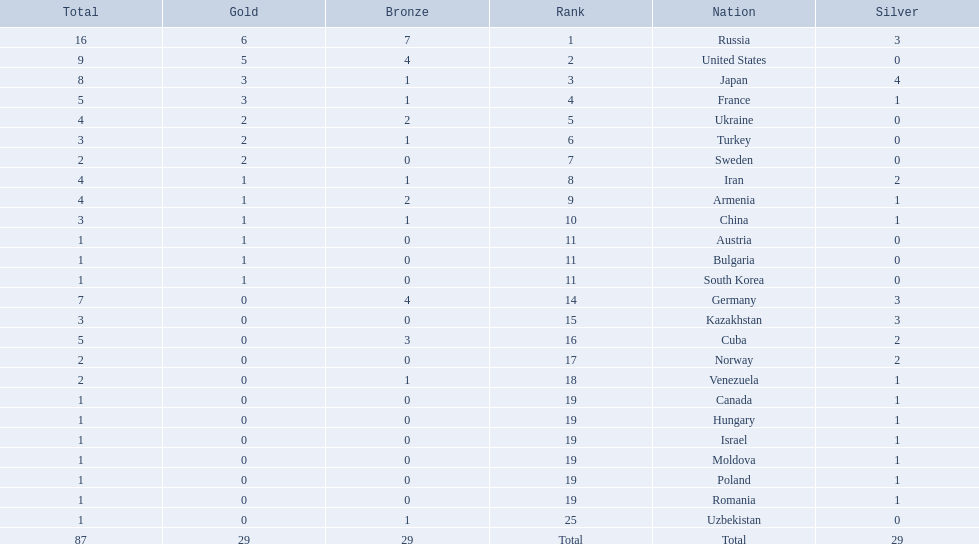Which nations only won less then 5 medals? Ukraine, Turkey, Sweden, Iran, Armenia, China, Austria, Bulgaria, South Korea, Germany, Kazakhstan, Norway, Venezuela, Canada, Hungary, Israel, Moldova, Poland, Romania, Uzbekistan. Which of these were not asian nations? Ukraine, Turkey, Sweden, Iran, Armenia, Austria, Bulgaria, Germany, Kazakhstan, Norway, Venezuela, Canada, Hungary, Israel, Moldova, Poland, Romania, Uzbekistan. Which of those did not win any silver medals? Ukraine, Turkey, Sweden, Austria, Bulgaria, Uzbekistan. Which ones of these had only one medal total? Austria, Bulgaria, Uzbekistan. Which of those would be listed first alphabetically? Austria. 